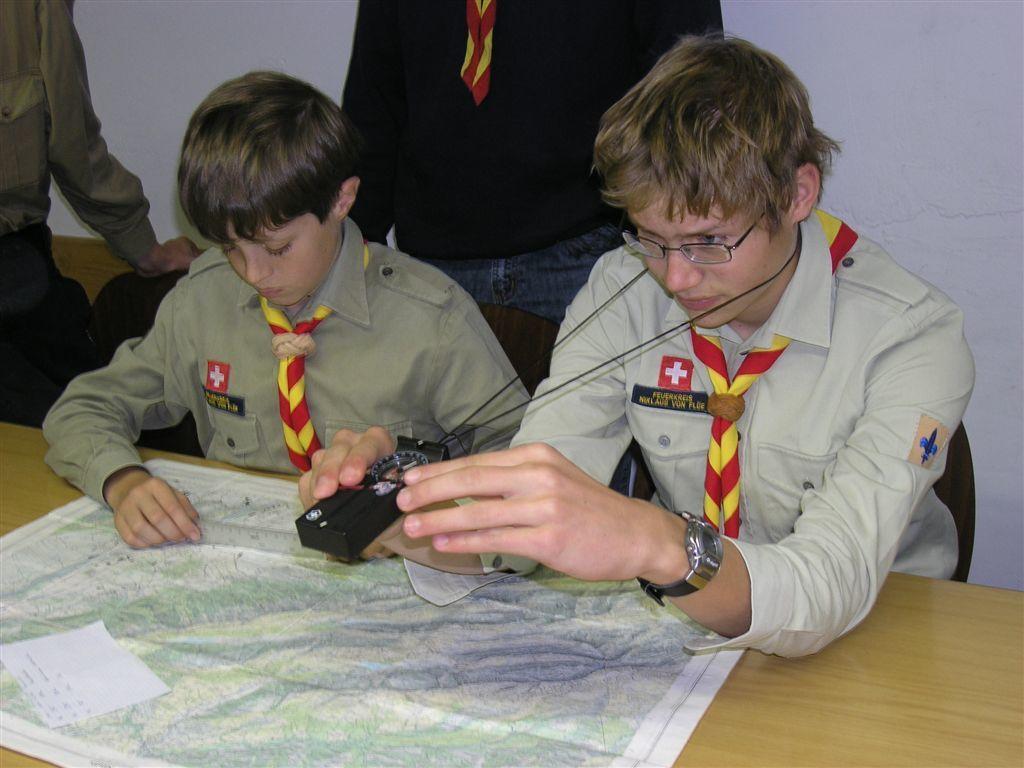Please provide a concise description of this image. In this image there are two boys sitting on the chairs. Before them there is a table having papers. Right side there is a boy holding an object. He is wearing spectacles and a watch. Behind them there are two people standing. Background there is a wall. 